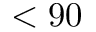<formula> <loc_0><loc_0><loc_500><loc_500>< 9 0</formula> 